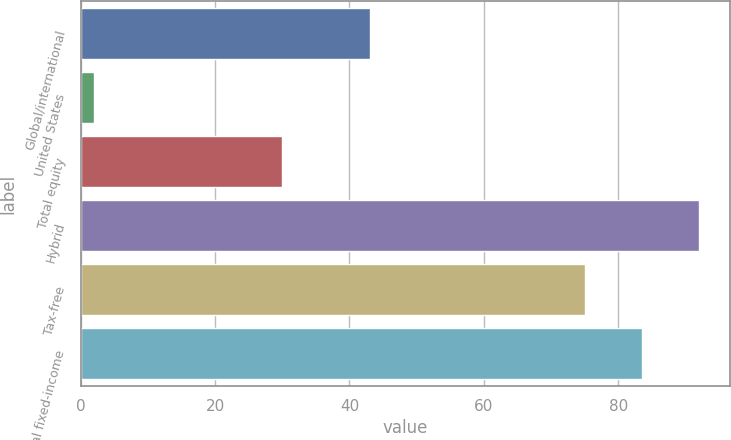Convert chart. <chart><loc_0><loc_0><loc_500><loc_500><bar_chart><fcel>Global/international<fcel>United States<fcel>Total equity<fcel>Hybrid<fcel>Tax-free<fcel>Total fixed-income<nl><fcel>43<fcel>2<fcel>30<fcel>92<fcel>75<fcel>83.5<nl></chart> 